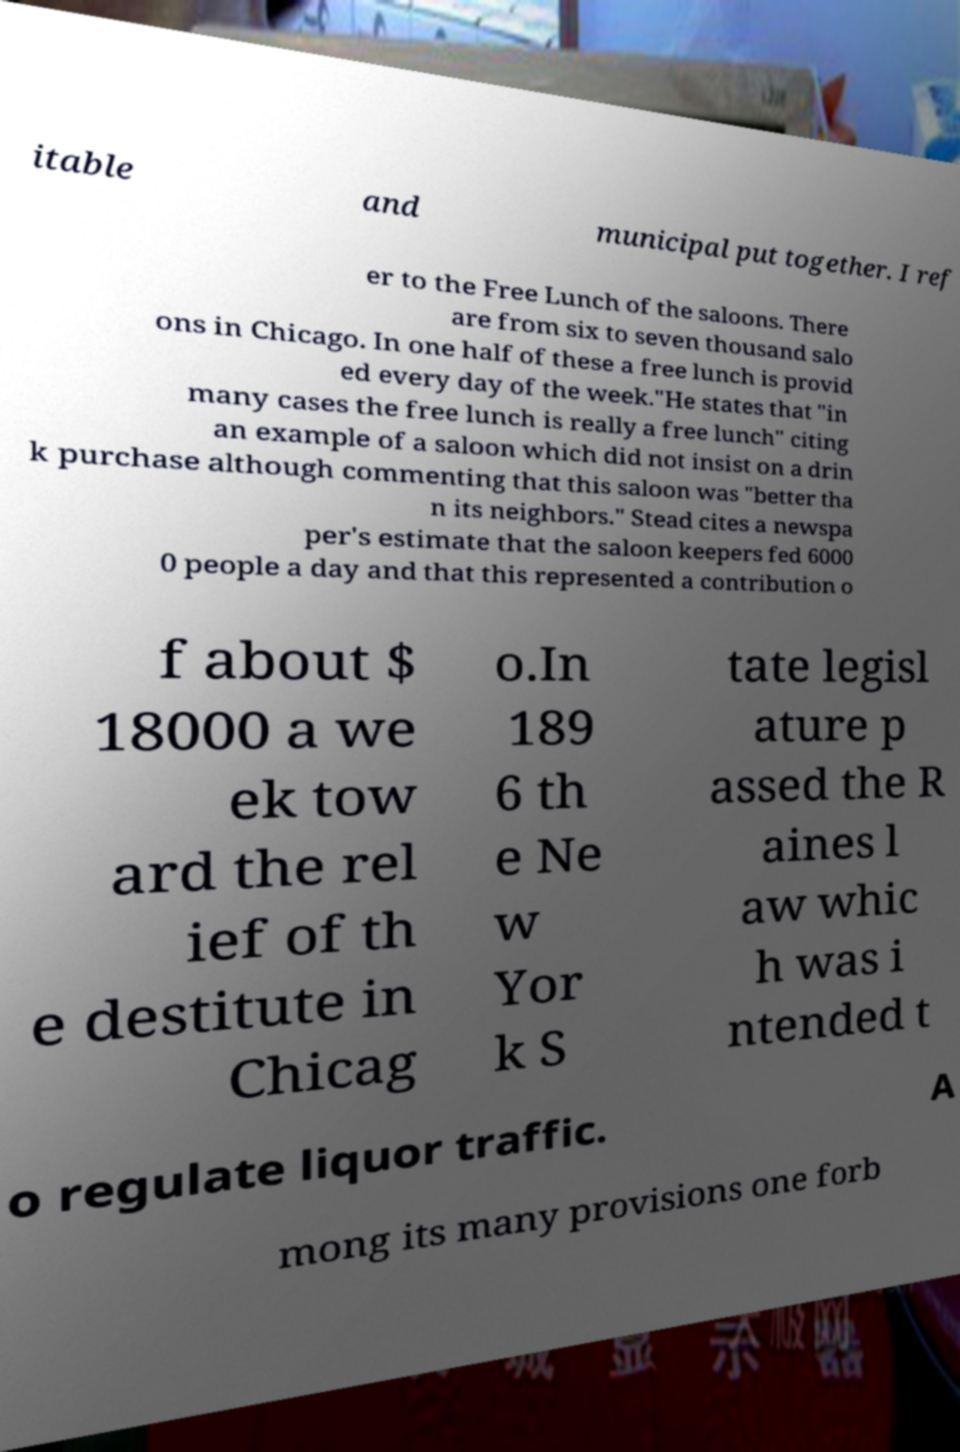Could you extract and type out the text from this image? itable and municipal put together. I ref er to the Free Lunch of the saloons. There are from six to seven thousand salo ons in Chicago. In one half of these a free lunch is provid ed every day of the week."He states that "in many cases the free lunch is really a free lunch" citing an example of a saloon which did not insist on a drin k purchase although commenting that this saloon was "better tha n its neighbors." Stead cites a newspa per's estimate that the saloon keepers fed 6000 0 people a day and that this represented a contribution o f about $ 18000 a we ek tow ard the rel ief of th e destitute in Chicag o.In 189 6 th e Ne w Yor k S tate legisl ature p assed the R aines l aw whic h was i ntended t o regulate liquor traffic. A mong its many provisions one forb 